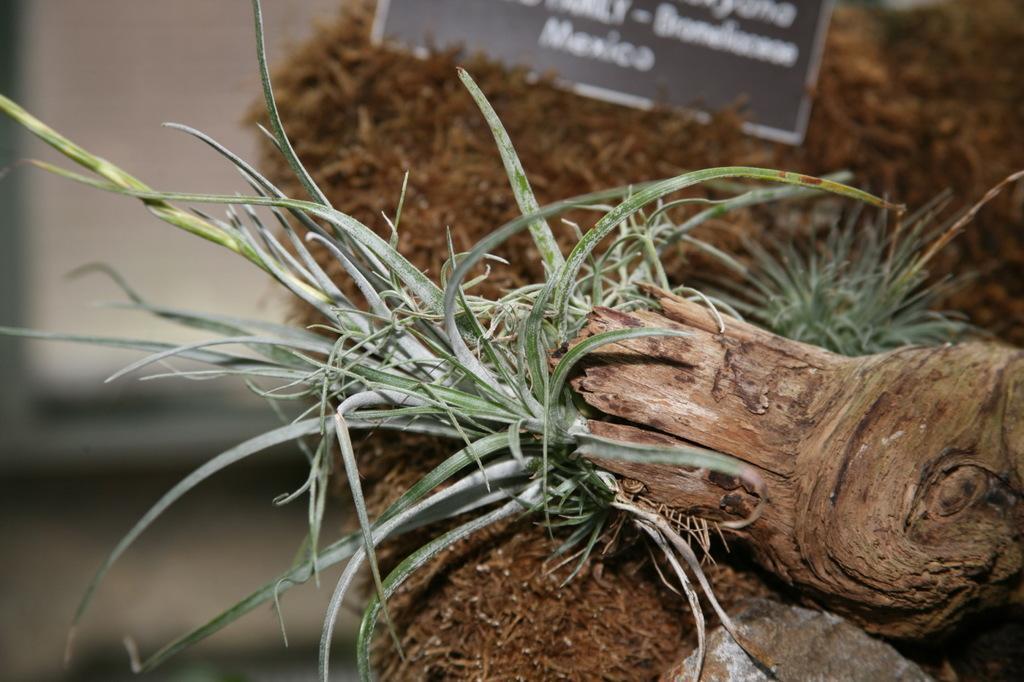Can you describe this image briefly? In this picture we can see grass and a name board. 